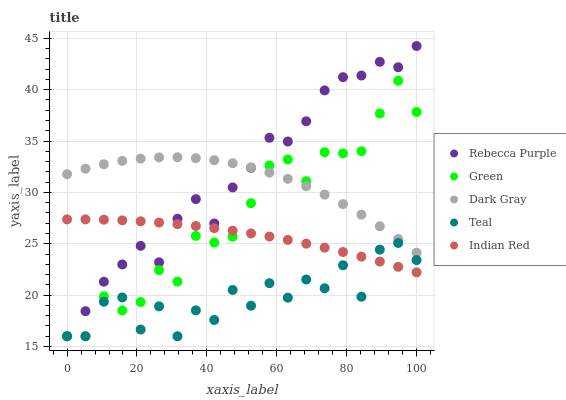Does Teal have the minimum area under the curve?
Answer yes or no. Yes. Does Rebecca Purple have the maximum area under the curve?
Answer yes or no. Yes. Does Indian Red have the minimum area under the curve?
Answer yes or no. No. Does Indian Red have the maximum area under the curve?
Answer yes or no. No. Is Indian Red the smoothest?
Answer yes or no. Yes. Is Teal the roughest?
Answer yes or no. Yes. Is Green the smoothest?
Answer yes or no. No. Is Green the roughest?
Answer yes or no. No. Does Green have the lowest value?
Answer yes or no. Yes. Does Indian Red have the lowest value?
Answer yes or no. No. Does Rebecca Purple have the highest value?
Answer yes or no. Yes. Does Indian Red have the highest value?
Answer yes or no. No. Is Indian Red less than Dark Gray?
Answer yes or no. Yes. Is Dark Gray greater than Indian Red?
Answer yes or no. Yes. Does Rebecca Purple intersect Indian Red?
Answer yes or no. Yes. Is Rebecca Purple less than Indian Red?
Answer yes or no. No. Is Rebecca Purple greater than Indian Red?
Answer yes or no. No. Does Indian Red intersect Dark Gray?
Answer yes or no. No. 